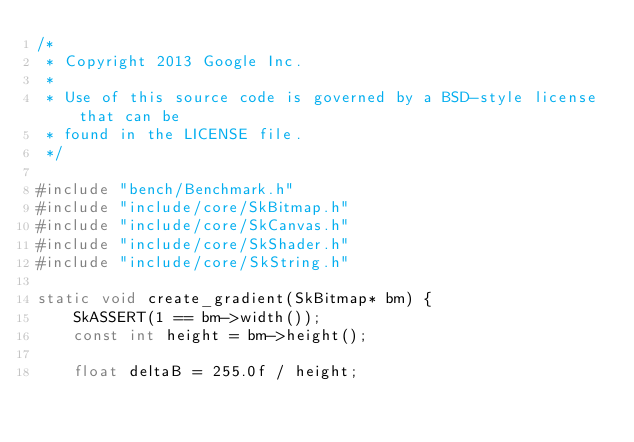<code> <loc_0><loc_0><loc_500><loc_500><_C++_>/*
 * Copyright 2013 Google Inc.
 *
 * Use of this source code is governed by a BSD-style license that can be
 * found in the LICENSE file.
 */

#include "bench/Benchmark.h"
#include "include/core/SkBitmap.h"
#include "include/core/SkCanvas.h"
#include "include/core/SkShader.h"
#include "include/core/SkString.h"

static void create_gradient(SkBitmap* bm) {
    SkASSERT(1 == bm->width());
    const int height = bm->height();

    float deltaB = 255.0f / height;</code> 